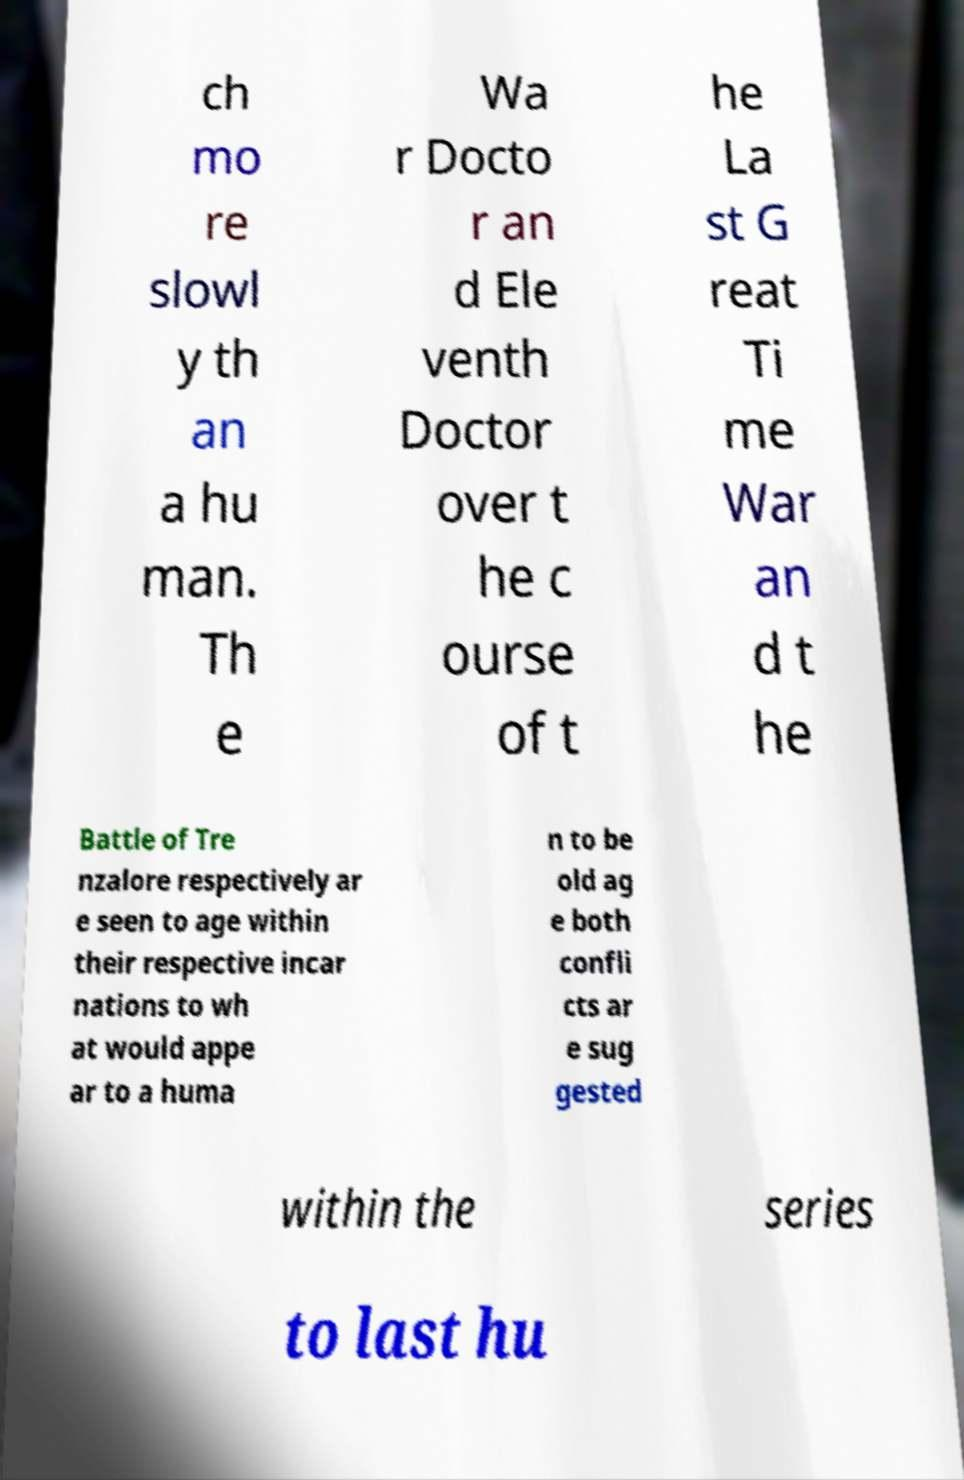Can you accurately transcribe the text from the provided image for me? ch mo re slowl y th an a hu man. Th e Wa r Docto r an d Ele venth Doctor over t he c ourse of t he La st G reat Ti me War an d t he Battle of Tre nzalore respectively ar e seen to age within their respective incar nations to wh at would appe ar to a huma n to be old ag e both confli cts ar e sug gested within the series to last hu 